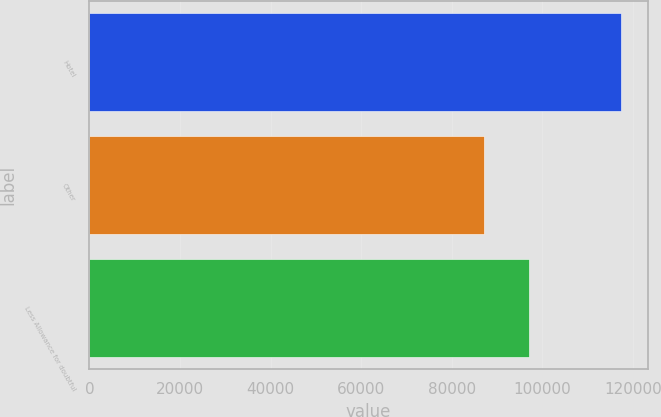<chart> <loc_0><loc_0><loc_500><loc_500><bar_chart><fcel>Hotel<fcel>Other<fcel>Less Allowance for doubtful<nl><fcel>117390<fcel>87165<fcel>97106<nl></chart> 